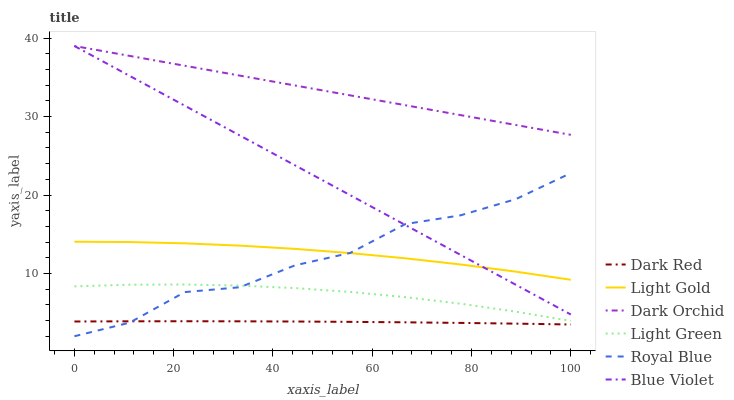Does Dark Red have the minimum area under the curve?
Answer yes or no. Yes. Does Dark Orchid have the maximum area under the curve?
Answer yes or no. Yes. Does Royal Blue have the minimum area under the curve?
Answer yes or no. No. Does Royal Blue have the maximum area under the curve?
Answer yes or no. No. Is Blue Violet the smoothest?
Answer yes or no. Yes. Is Royal Blue the roughest?
Answer yes or no. Yes. Is Dark Orchid the smoothest?
Answer yes or no. No. Is Dark Orchid the roughest?
Answer yes or no. No. Does Royal Blue have the lowest value?
Answer yes or no. Yes. Does Dark Orchid have the lowest value?
Answer yes or no. No. Does Blue Violet have the highest value?
Answer yes or no. Yes. Does Royal Blue have the highest value?
Answer yes or no. No. Is Light Green less than Blue Violet?
Answer yes or no. Yes. Is Dark Orchid greater than Dark Red?
Answer yes or no. Yes. Does Light Green intersect Royal Blue?
Answer yes or no. Yes. Is Light Green less than Royal Blue?
Answer yes or no. No. Is Light Green greater than Royal Blue?
Answer yes or no. No. Does Light Green intersect Blue Violet?
Answer yes or no. No. 